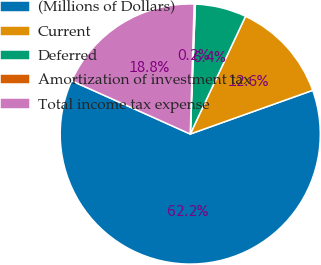Convert chart. <chart><loc_0><loc_0><loc_500><loc_500><pie_chart><fcel>(Millions of Dollars)<fcel>Current<fcel>Deferred<fcel>Amortization of investment tax<fcel>Total income tax expense<nl><fcel>62.17%<fcel>12.56%<fcel>6.36%<fcel>0.15%<fcel>18.76%<nl></chart> 